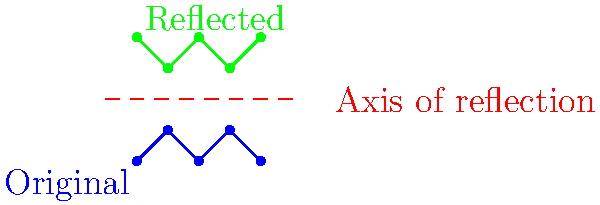In the diagram, a football team's defensive formation (blue) is reflected across an axis (red dashed line) to create a new formation (green). If the original formation is described by the coordinates A(0,0), B(1,1), C(2,0), D(3,1), and E(4,0), what are the coordinates of point C in the reflected formation? To find the coordinates of point C in the reflected formation, we need to follow these steps:

1) First, we identify that the axis of reflection is a horizontal line at y = 2.

2) The reflection of a point across a horizontal line at y = k is given by the formula:
   $$(x, y) \rightarrow (x, 2k - y)$$

3) The original coordinates of point C are (2,0).

4) Applying the reflection formula:
   $$x' = x = 2$$
   $$y' = 2k - y = 2(2) - 0 = 4$$

5) Therefore, the coordinates of point C in the reflected formation are (2,4).

This method of reflection can be used to analyze how offensive formations might appear from a defensive perspective, or vice versa, providing insights into strategic positioning on the field.
Answer: (2,4) 